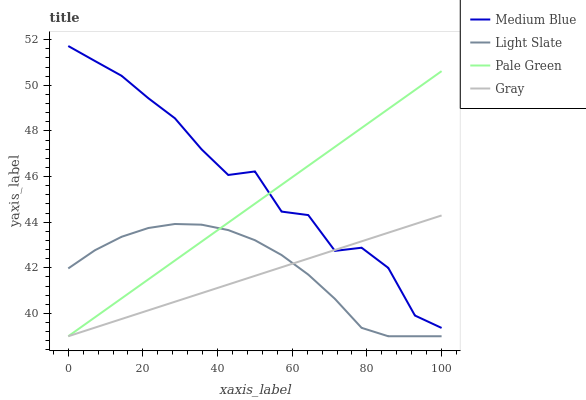Does Gray have the minimum area under the curve?
Answer yes or no. Yes. Does Medium Blue have the maximum area under the curve?
Answer yes or no. Yes. Does Pale Green have the minimum area under the curve?
Answer yes or no. No. Does Pale Green have the maximum area under the curve?
Answer yes or no. No. Is Gray the smoothest?
Answer yes or no. Yes. Is Medium Blue the roughest?
Answer yes or no. Yes. Is Pale Green the smoothest?
Answer yes or no. No. Is Pale Green the roughest?
Answer yes or no. No. Does Light Slate have the lowest value?
Answer yes or no. Yes. Does Medium Blue have the lowest value?
Answer yes or no. No. Does Medium Blue have the highest value?
Answer yes or no. Yes. Does Gray have the highest value?
Answer yes or no. No. Is Light Slate less than Medium Blue?
Answer yes or no. Yes. Is Medium Blue greater than Light Slate?
Answer yes or no. Yes. Does Pale Green intersect Medium Blue?
Answer yes or no. Yes. Is Pale Green less than Medium Blue?
Answer yes or no. No. Is Pale Green greater than Medium Blue?
Answer yes or no. No. Does Light Slate intersect Medium Blue?
Answer yes or no. No. 